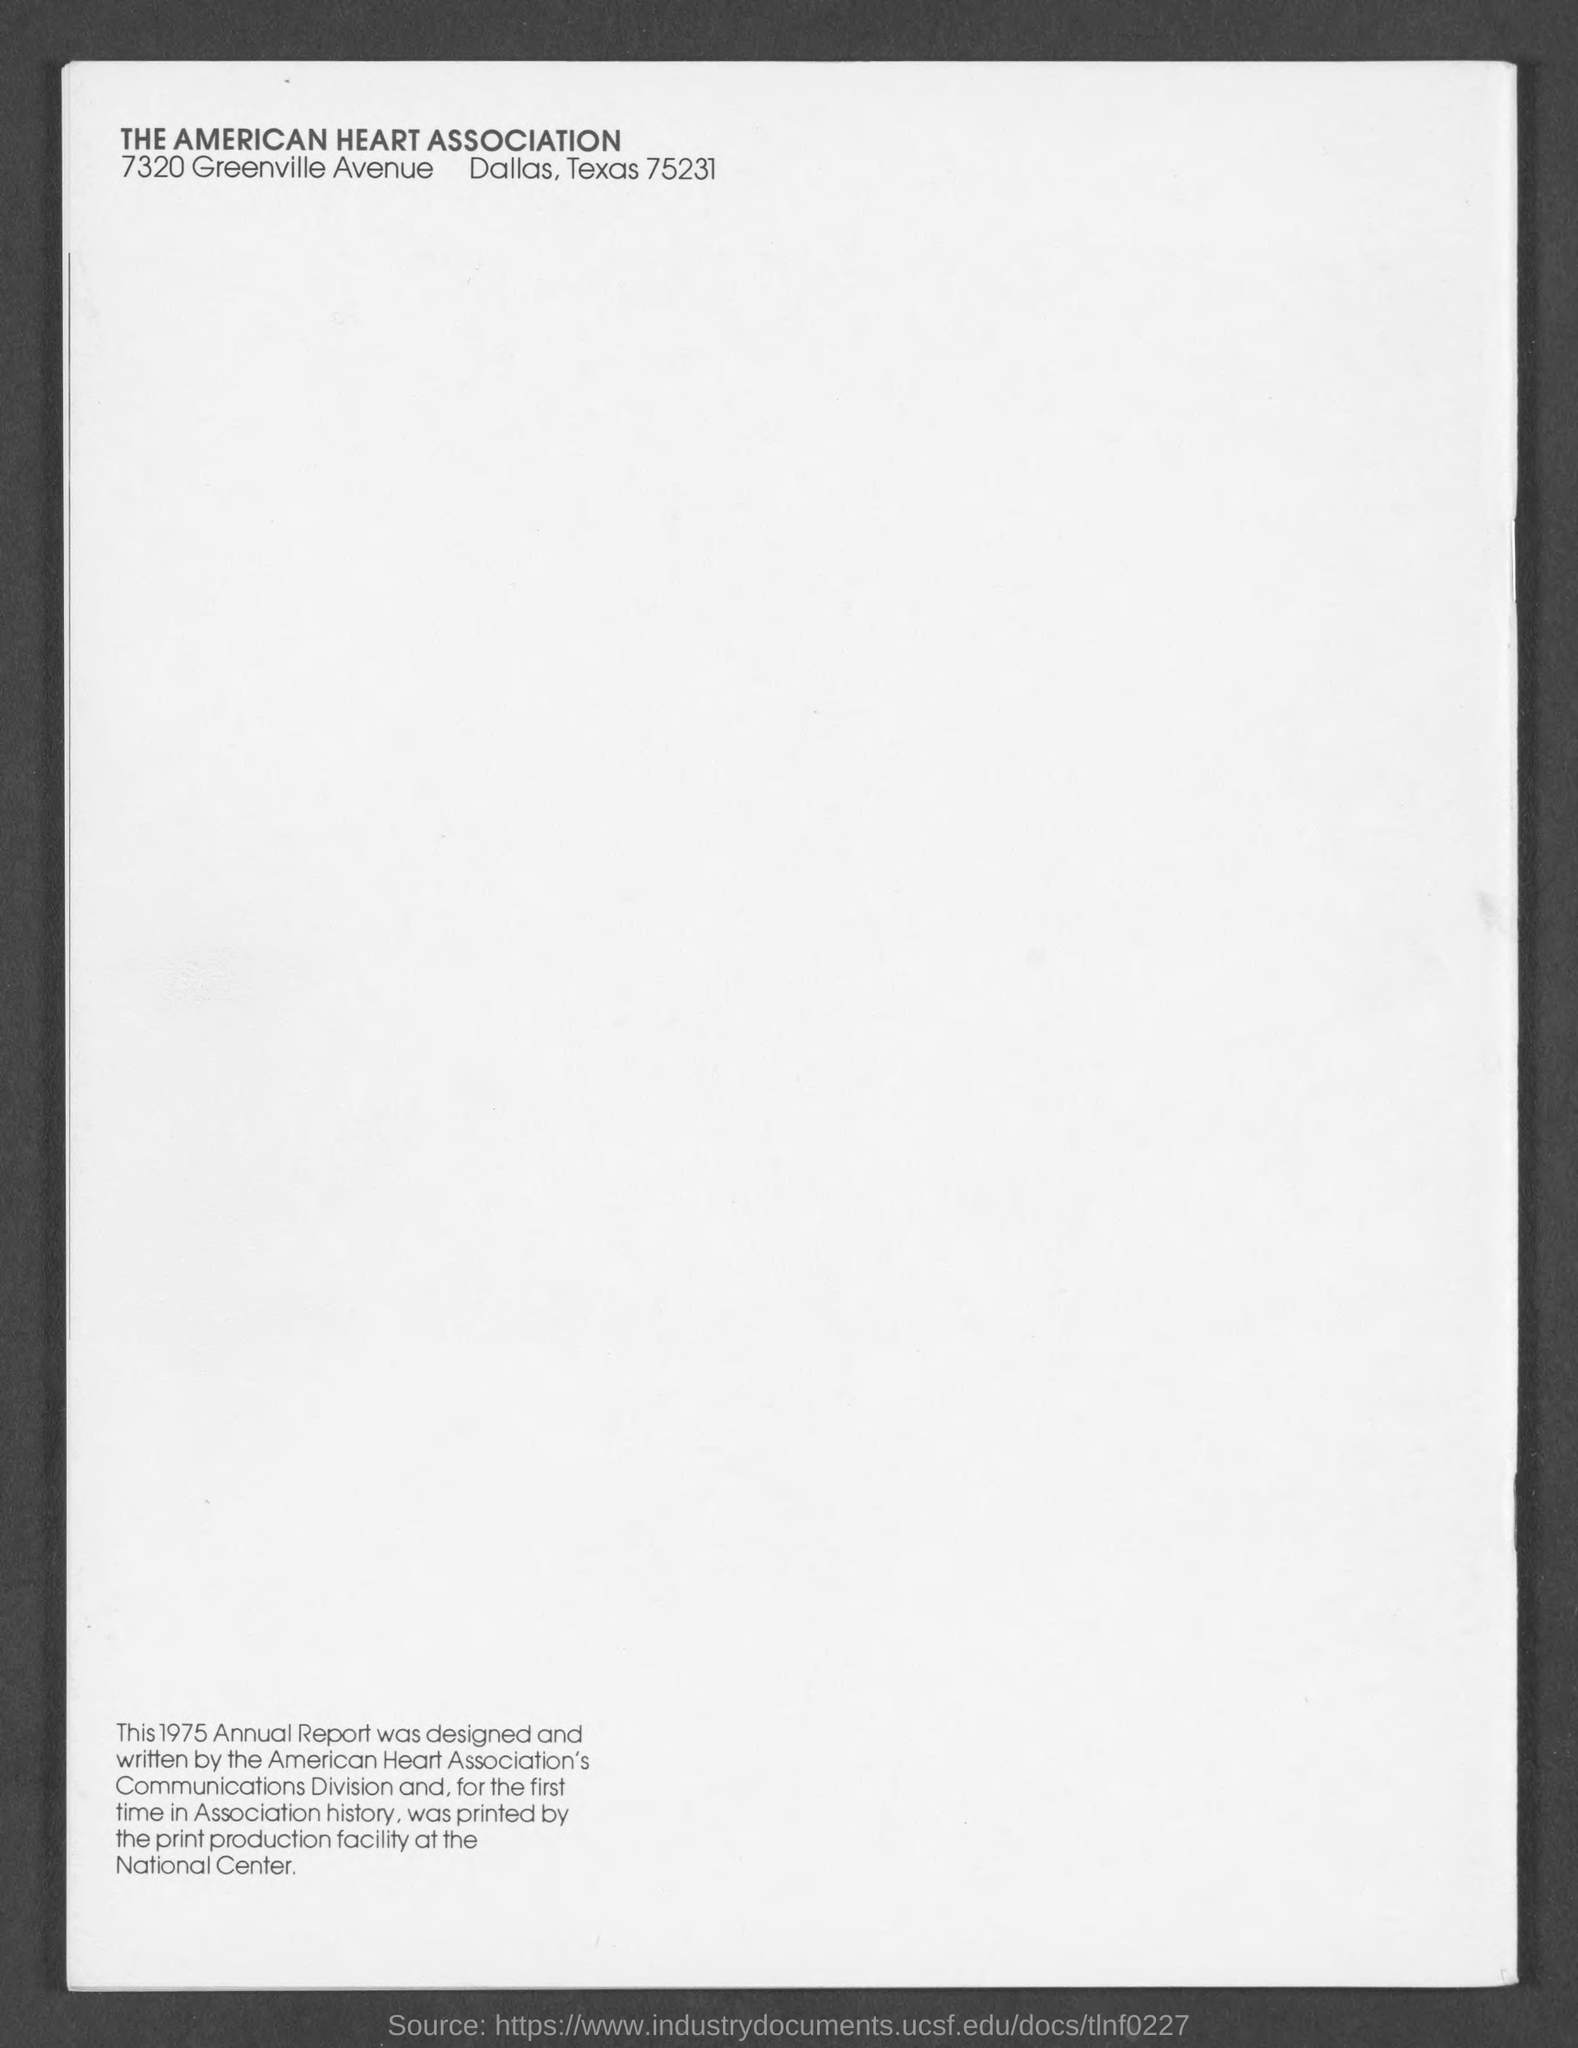What is the name of the association mentioned in the given form ?
Offer a terse response. The American Heart Association. 